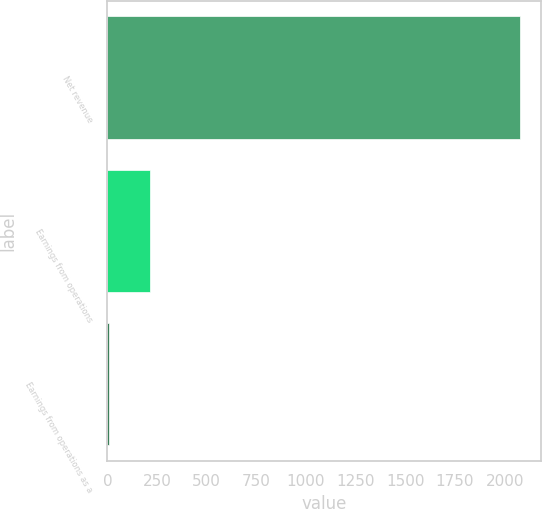Convert chart. <chart><loc_0><loc_0><loc_500><loc_500><bar_chart><fcel>Net revenue<fcel>Earnings from operations<fcel>Earnings from operations as a<nl><fcel>2078<fcel>214.19<fcel>7.1<nl></chart> 